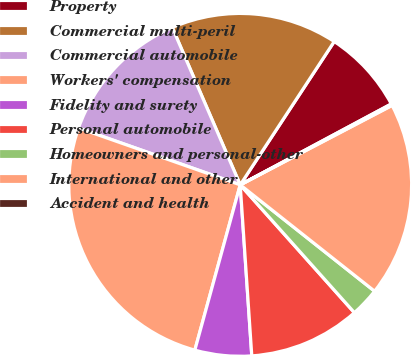<chart> <loc_0><loc_0><loc_500><loc_500><pie_chart><fcel>Property<fcel>Commercial multi-peril<fcel>Commercial automobile<fcel>Workers' compensation<fcel>Fidelity and surety<fcel>Personal automobile<fcel>Homeowners and personal-other<fcel>International and other<fcel>Accident and health<nl><fcel>7.94%<fcel>15.73%<fcel>13.13%<fcel>26.12%<fcel>5.34%<fcel>10.53%<fcel>2.74%<fcel>18.33%<fcel>0.15%<nl></chart> 